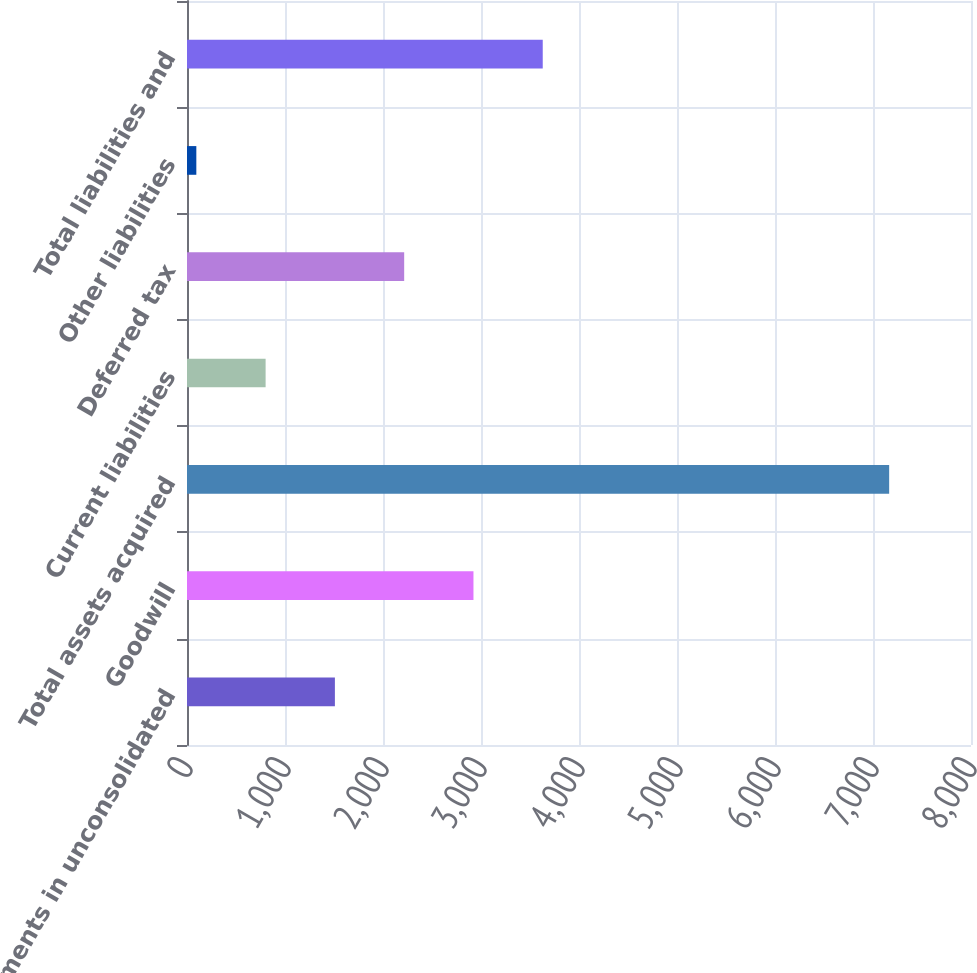Convert chart. <chart><loc_0><loc_0><loc_500><loc_500><bar_chart><fcel>Investments in unconsolidated<fcel>Goodwill<fcel>Total assets acquired<fcel>Current liabilities<fcel>Deferred tax<fcel>Other liabilities<fcel>Total liabilities and<nl><fcel>1509.14<fcel>2923.08<fcel>7164.9<fcel>802.17<fcel>2216.11<fcel>95.2<fcel>3630.05<nl></chart> 